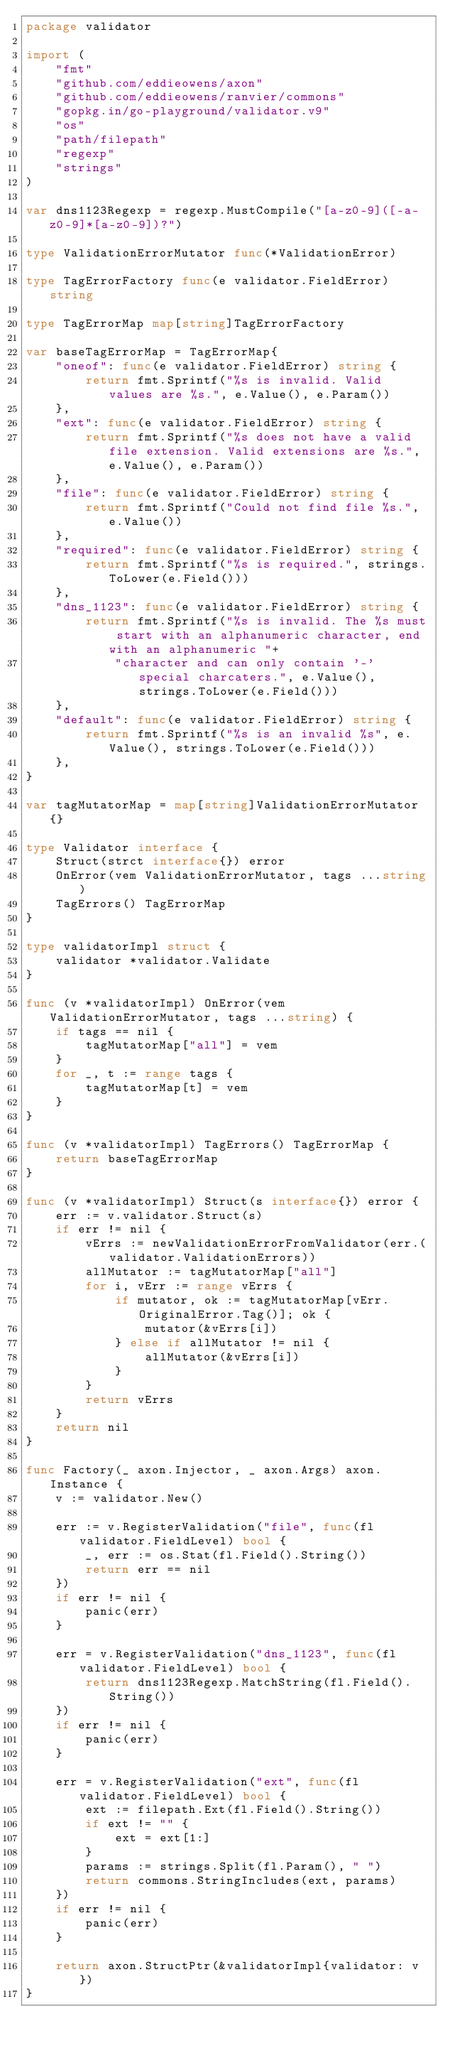Convert code to text. <code><loc_0><loc_0><loc_500><loc_500><_Go_>package validator

import (
	"fmt"
	"github.com/eddieowens/axon"
	"github.com/eddieowens/ranvier/commons"
	"gopkg.in/go-playground/validator.v9"
	"os"
	"path/filepath"
	"regexp"
	"strings"
)

var dns1123Regexp = regexp.MustCompile("[a-z0-9]([-a-z0-9]*[a-z0-9])?")

type ValidationErrorMutator func(*ValidationError)

type TagErrorFactory func(e validator.FieldError) string

type TagErrorMap map[string]TagErrorFactory

var baseTagErrorMap = TagErrorMap{
	"oneof": func(e validator.FieldError) string {
		return fmt.Sprintf("%s is invalid. Valid values are %s.", e.Value(), e.Param())
	},
	"ext": func(e validator.FieldError) string {
		return fmt.Sprintf("%s does not have a valid file extension. Valid extensions are %s.", e.Value(), e.Param())
	},
	"file": func(e validator.FieldError) string {
		return fmt.Sprintf("Could not find file %s.", e.Value())
	},
	"required": func(e validator.FieldError) string {
		return fmt.Sprintf("%s is required.", strings.ToLower(e.Field()))
	},
	"dns_1123": func(e validator.FieldError) string {
		return fmt.Sprintf("%s is invalid. The %s must start with an alphanumeric character, end with an alphanumeric "+
			"character and can only contain '-' special charcaters.", e.Value(), strings.ToLower(e.Field()))
	},
	"default": func(e validator.FieldError) string {
		return fmt.Sprintf("%s is an invalid %s", e.Value(), strings.ToLower(e.Field()))
	},
}

var tagMutatorMap = map[string]ValidationErrorMutator{}

type Validator interface {
	Struct(strct interface{}) error
	OnError(vem ValidationErrorMutator, tags ...string)
	TagErrors() TagErrorMap
}

type validatorImpl struct {
	validator *validator.Validate
}

func (v *validatorImpl) OnError(vem ValidationErrorMutator, tags ...string) {
	if tags == nil {
		tagMutatorMap["all"] = vem
	}
	for _, t := range tags {
		tagMutatorMap[t] = vem
	}
}

func (v *validatorImpl) TagErrors() TagErrorMap {
	return baseTagErrorMap
}

func (v *validatorImpl) Struct(s interface{}) error {
	err := v.validator.Struct(s)
	if err != nil {
		vErrs := newValidationErrorFromValidator(err.(validator.ValidationErrors))
		allMutator := tagMutatorMap["all"]
		for i, vErr := range vErrs {
			if mutator, ok := tagMutatorMap[vErr.OriginalError.Tag()]; ok {
				mutator(&vErrs[i])
			} else if allMutator != nil {
				allMutator(&vErrs[i])
			}
		}
		return vErrs
	}
	return nil
}

func Factory(_ axon.Injector, _ axon.Args) axon.Instance {
	v := validator.New()

	err := v.RegisterValidation("file", func(fl validator.FieldLevel) bool {
		_, err := os.Stat(fl.Field().String())
		return err == nil
	})
	if err != nil {
		panic(err)
	}

	err = v.RegisterValidation("dns_1123", func(fl validator.FieldLevel) bool {
		return dns1123Regexp.MatchString(fl.Field().String())
	})
	if err != nil {
		panic(err)
	}

	err = v.RegisterValidation("ext", func(fl validator.FieldLevel) bool {
		ext := filepath.Ext(fl.Field().String())
		if ext != "" {
			ext = ext[1:]
		}
		params := strings.Split(fl.Param(), " ")
		return commons.StringIncludes(ext, params)
	})
	if err != nil {
		panic(err)
	}

	return axon.StructPtr(&validatorImpl{validator: v})
}
</code> 